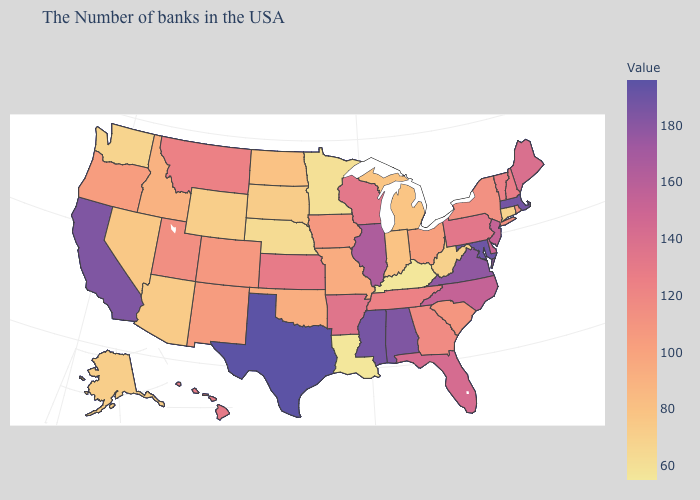Among the states that border New Jersey , does Pennsylvania have the lowest value?
Answer briefly. No. Which states have the lowest value in the USA?
Short answer required. Kentucky, Louisiana. Does Indiana have a lower value than Virginia?
Write a very short answer. Yes. Does the map have missing data?
Concise answer only. No. 